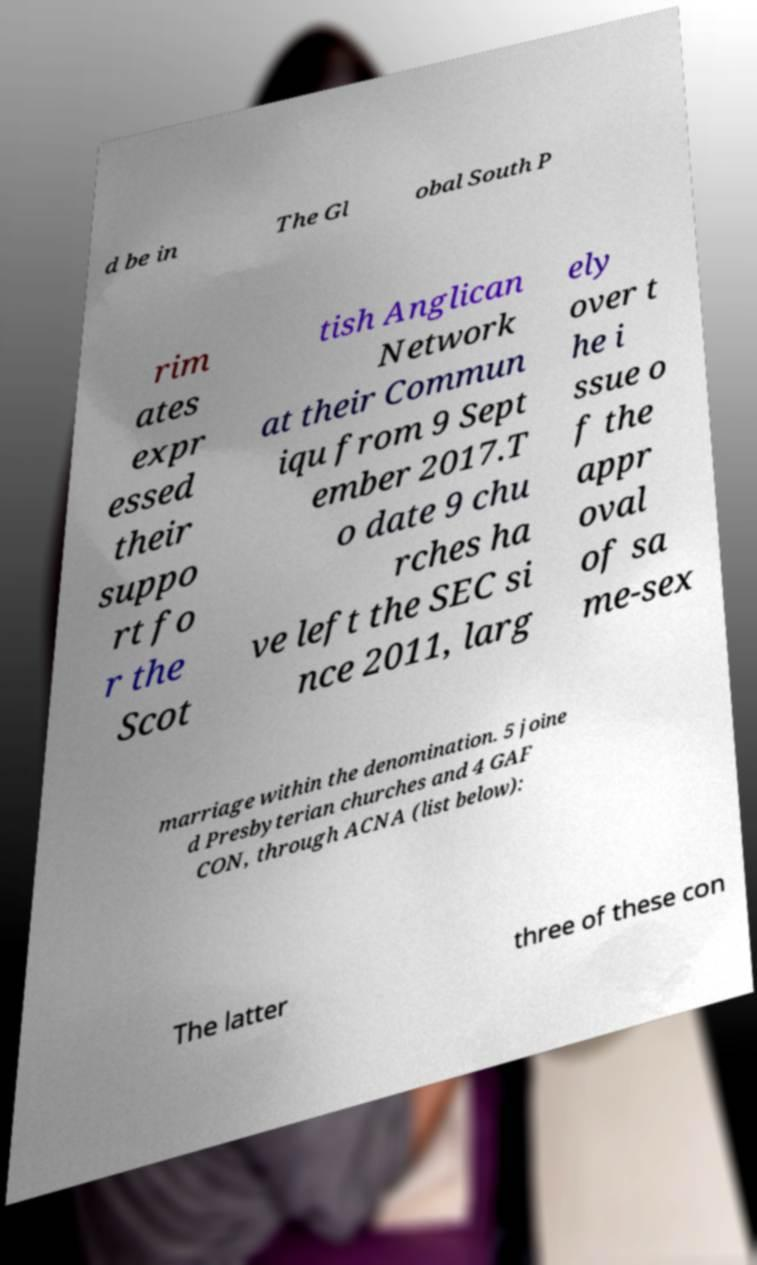Can you accurately transcribe the text from the provided image for me? d be in The Gl obal South P rim ates expr essed their suppo rt fo r the Scot tish Anglican Network at their Commun iqu from 9 Sept ember 2017.T o date 9 chu rches ha ve left the SEC si nce 2011, larg ely over t he i ssue o f the appr oval of sa me-sex marriage within the denomination. 5 joine d Presbyterian churches and 4 GAF CON, through ACNA (list below): The latter three of these con 